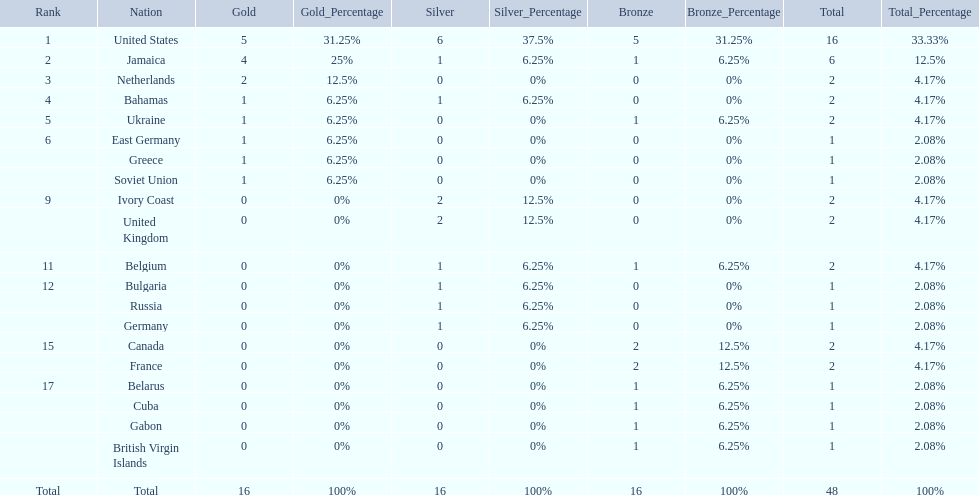Which countries competed in the 60 meters competition? United States, Jamaica, Netherlands, Bahamas, Ukraine, East Germany, Greece, Soviet Union, Ivory Coast, United Kingdom, Belgium, Bulgaria, Russia, Germany, Canada, France, Belarus, Cuba, Gabon, British Virgin Islands. And how many gold medals did they win? 5, 4, 2, 1, 1, 1, 1, 1, 0, 0, 0, 0, 0, 0, 0, 0, 0, 0, 0, 0. Of those countries, which won the second highest number gold medals? Jamaica. 